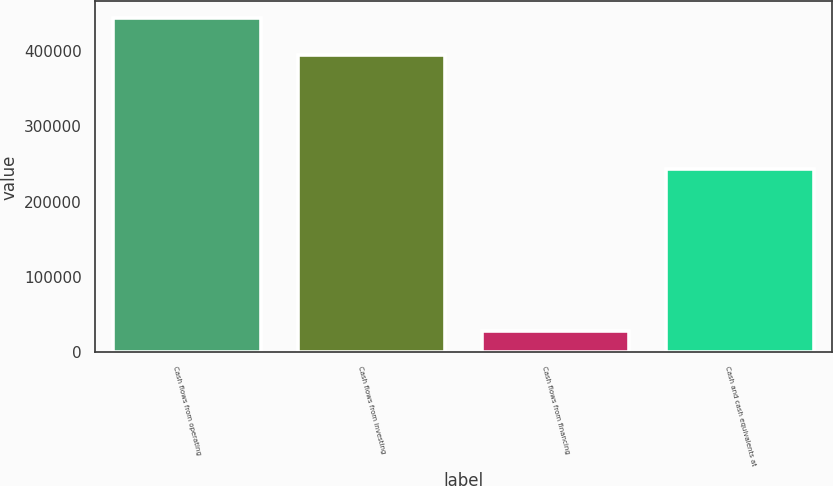<chart> <loc_0><loc_0><loc_500><loc_500><bar_chart><fcel>Cash flows from operating<fcel>Cash flows from investing<fcel>Cash flows from financing<fcel>Cash and cash equivalents at<nl><fcel>443652<fcel>394064<fcel>28269<fcel>243415<nl></chart> 